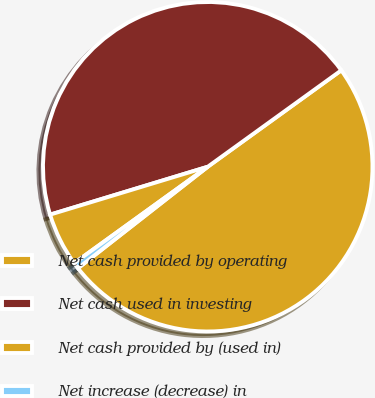Convert chart. <chart><loc_0><loc_0><loc_500><loc_500><pie_chart><fcel>Net cash provided by operating<fcel>Net cash used in investing<fcel>Net cash provided by (used in)<fcel>Net increase (decrease) in<nl><fcel>49.39%<fcel>44.74%<fcel>5.26%<fcel>0.61%<nl></chart> 